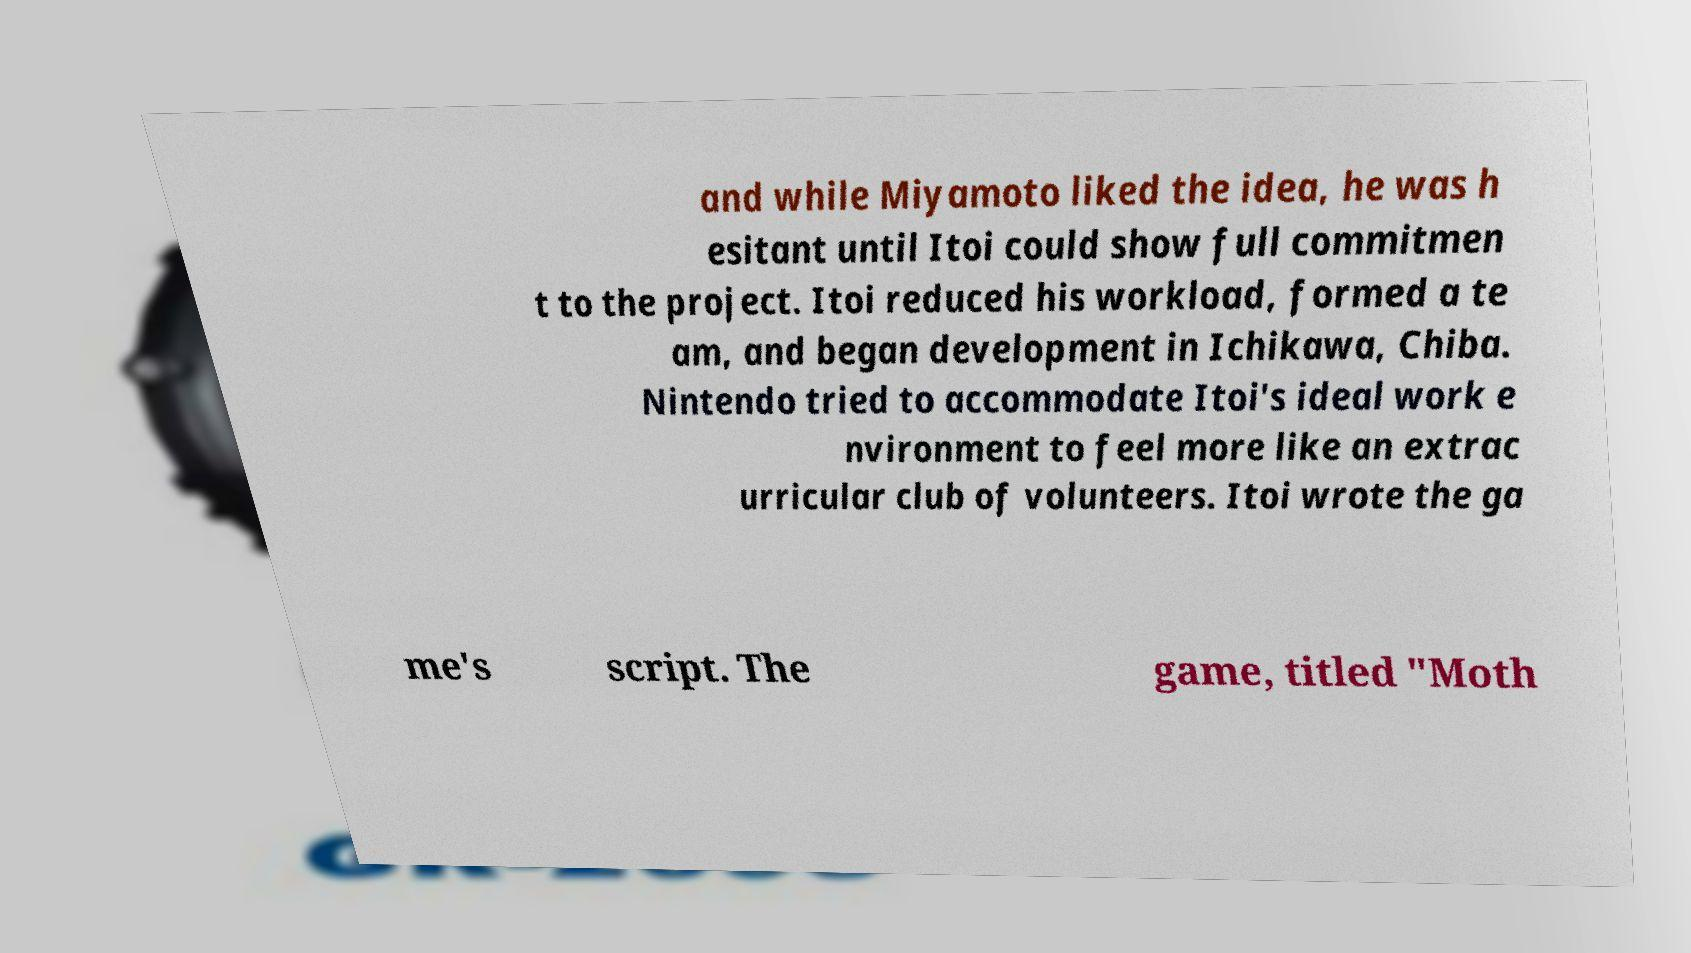For documentation purposes, I need the text within this image transcribed. Could you provide that? and while Miyamoto liked the idea, he was h esitant until Itoi could show full commitmen t to the project. Itoi reduced his workload, formed a te am, and began development in Ichikawa, Chiba. Nintendo tried to accommodate Itoi's ideal work e nvironment to feel more like an extrac urricular club of volunteers. Itoi wrote the ga me's script. The game, titled "Moth 